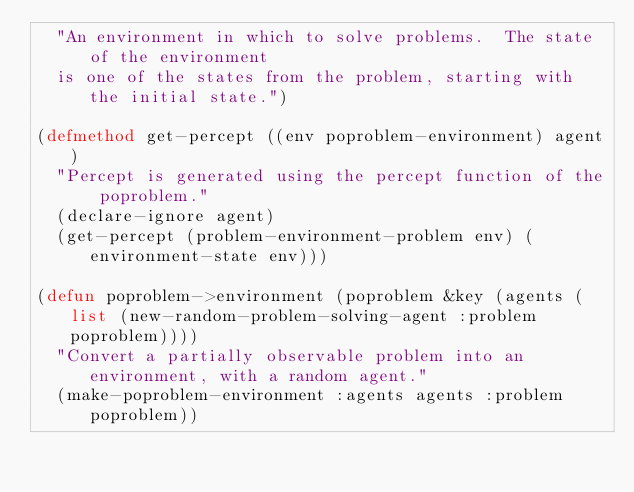Convert code to text. <code><loc_0><loc_0><loc_500><loc_500><_Lisp_>  "An environment in which to solve problems.  The state of the environment
  is one of the states from the problem, starting with the initial state.")

(defmethod get-percept ((env poproblem-environment) agent)
  "Percept is generated using the percept function of the poproblem."
  (declare-ignore agent)
  (get-percept (problem-environment-problem env) (environment-state env)))

(defun poproblem->environment (poproblem &key (agents (list (new-random-problem-solving-agent :problem poproblem))))
  "Convert a partially observable problem into an environment, with a random agent."
  (make-poproblem-environment :agents agents :problem poproblem))

</code> 